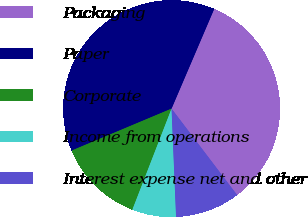Convert chart. <chart><loc_0><loc_0><loc_500><loc_500><pie_chart><fcel>Packaging<fcel>Paper<fcel>Corporate<fcel>Income from operations<fcel>Interest expense net and other<nl><fcel>33.23%<fcel>37.76%<fcel>12.79%<fcel>6.55%<fcel>9.67%<nl></chart> 